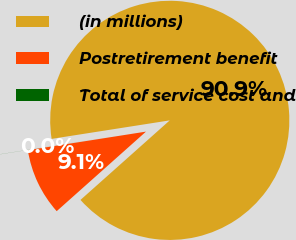Convert chart. <chart><loc_0><loc_0><loc_500><loc_500><pie_chart><fcel>(in millions)<fcel>Postretirement benefit<fcel>Total of service cost and<nl><fcel>90.89%<fcel>9.1%<fcel>0.01%<nl></chart> 